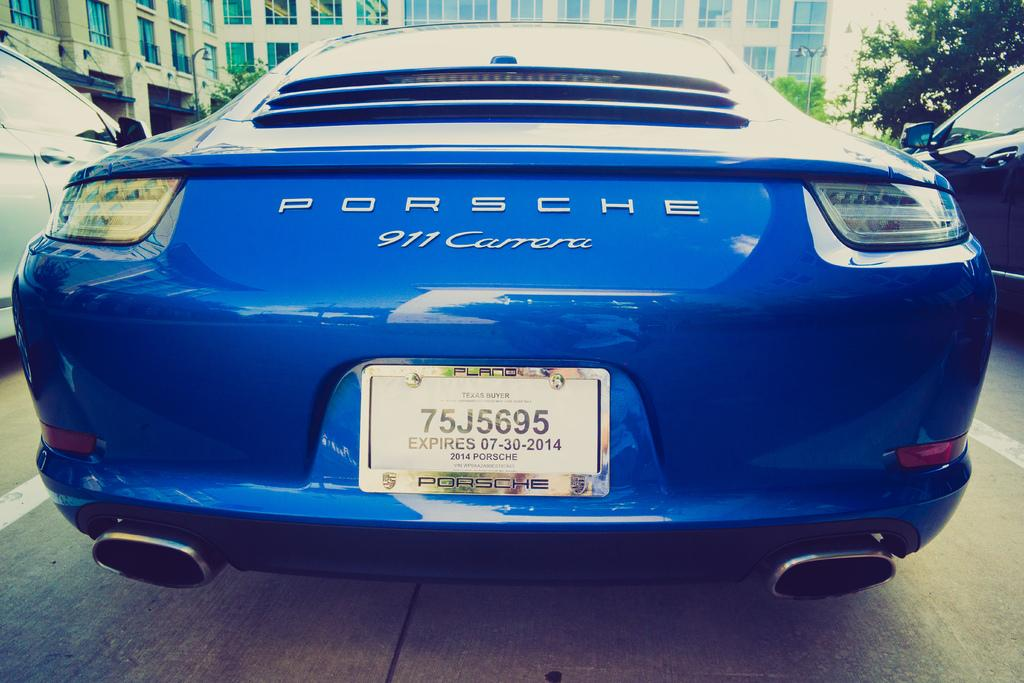What type of vehicles can be seen on the road in the image? There are cars on the road in the image. What can be seen in the background of the image? There are trees, poles, and a building in the background of the image. What type of hill can be seen in the image? There is no hill present in the image. 